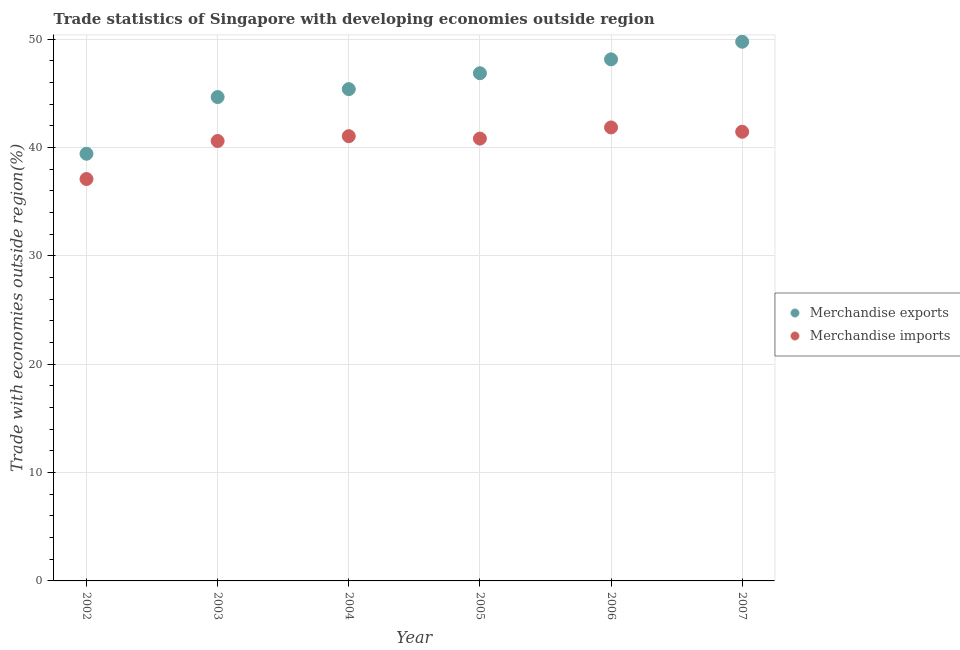What is the merchandise exports in 2005?
Provide a succinct answer. 46.87. Across all years, what is the maximum merchandise imports?
Make the answer very short. 41.87. Across all years, what is the minimum merchandise exports?
Provide a short and direct response. 39.44. What is the total merchandise exports in the graph?
Your answer should be compact. 274.31. What is the difference between the merchandise exports in 2004 and that in 2007?
Keep it short and to the point. -4.38. What is the difference between the merchandise imports in 2006 and the merchandise exports in 2002?
Ensure brevity in your answer.  2.43. What is the average merchandise imports per year?
Your response must be concise. 40.49. In the year 2003, what is the difference between the merchandise exports and merchandise imports?
Provide a short and direct response. 4.06. In how many years, is the merchandise exports greater than 30 %?
Your answer should be compact. 6. What is the ratio of the merchandise exports in 2005 to that in 2006?
Your answer should be compact. 0.97. What is the difference between the highest and the second highest merchandise imports?
Offer a very short reply. 0.4. What is the difference between the highest and the lowest merchandise exports?
Provide a short and direct response. 10.34. In how many years, is the merchandise imports greater than the average merchandise imports taken over all years?
Offer a very short reply. 5. Does the graph contain any zero values?
Provide a short and direct response. No. Does the graph contain grids?
Make the answer very short. Yes. Where does the legend appear in the graph?
Your answer should be compact. Center right. How are the legend labels stacked?
Provide a succinct answer. Vertical. What is the title of the graph?
Provide a short and direct response. Trade statistics of Singapore with developing economies outside region. Does "Excluding technical cooperation" appear as one of the legend labels in the graph?
Your response must be concise. No. What is the label or title of the X-axis?
Give a very brief answer. Year. What is the label or title of the Y-axis?
Offer a very short reply. Trade with economies outside region(%). What is the Trade with economies outside region(%) in Merchandise exports in 2002?
Make the answer very short. 39.44. What is the Trade with economies outside region(%) of Merchandise imports in 2002?
Offer a very short reply. 37.1. What is the Trade with economies outside region(%) in Merchandise exports in 2003?
Provide a short and direct response. 44.67. What is the Trade with economies outside region(%) in Merchandise imports in 2003?
Offer a very short reply. 40.61. What is the Trade with economies outside region(%) of Merchandise exports in 2004?
Ensure brevity in your answer.  45.4. What is the Trade with economies outside region(%) in Merchandise imports in 2004?
Keep it short and to the point. 41.06. What is the Trade with economies outside region(%) of Merchandise exports in 2005?
Provide a short and direct response. 46.87. What is the Trade with economies outside region(%) in Merchandise imports in 2005?
Your answer should be very brief. 40.84. What is the Trade with economies outside region(%) in Merchandise exports in 2006?
Provide a short and direct response. 48.15. What is the Trade with economies outside region(%) in Merchandise imports in 2006?
Offer a very short reply. 41.87. What is the Trade with economies outside region(%) in Merchandise exports in 2007?
Ensure brevity in your answer.  49.78. What is the Trade with economies outside region(%) of Merchandise imports in 2007?
Give a very brief answer. 41.47. Across all years, what is the maximum Trade with economies outside region(%) in Merchandise exports?
Ensure brevity in your answer.  49.78. Across all years, what is the maximum Trade with economies outside region(%) of Merchandise imports?
Make the answer very short. 41.87. Across all years, what is the minimum Trade with economies outside region(%) in Merchandise exports?
Provide a short and direct response. 39.44. Across all years, what is the minimum Trade with economies outside region(%) in Merchandise imports?
Your answer should be compact. 37.1. What is the total Trade with economies outside region(%) in Merchandise exports in the graph?
Your answer should be very brief. 274.31. What is the total Trade with economies outside region(%) of Merchandise imports in the graph?
Offer a terse response. 242.95. What is the difference between the Trade with economies outside region(%) of Merchandise exports in 2002 and that in 2003?
Keep it short and to the point. -5.23. What is the difference between the Trade with economies outside region(%) of Merchandise imports in 2002 and that in 2003?
Give a very brief answer. -3.51. What is the difference between the Trade with economies outside region(%) of Merchandise exports in 2002 and that in 2004?
Ensure brevity in your answer.  -5.96. What is the difference between the Trade with economies outside region(%) of Merchandise imports in 2002 and that in 2004?
Make the answer very short. -3.95. What is the difference between the Trade with economies outside region(%) of Merchandise exports in 2002 and that in 2005?
Make the answer very short. -7.43. What is the difference between the Trade with economies outside region(%) of Merchandise imports in 2002 and that in 2005?
Provide a short and direct response. -3.73. What is the difference between the Trade with economies outside region(%) in Merchandise exports in 2002 and that in 2006?
Offer a very short reply. -8.71. What is the difference between the Trade with economies outside region(%) in Merchandise imports in 2002 and that in 2006?
Keep it short and to the point. -4.76. What is the difference between the Trade with economies outside region(%) in Merchandise exports in 2002 and that in 2007?
Your answer should be very brief. -10.34. What is the difference between the Trade with economies outside region(%) of Merchandise imports in 2002 and that in 2007?
Your response must be concise. -4.36. What is the difference between the Trade with economies outside region(%) of Merchandise exports in 2003 and that in 2004?
Provide a succinct answer. -0.73. What is the difference between the Trade with economies outside region(%) in Merchandise imports in 2003 and that in 2004?
Give a very brief answer. -0.45. What is the difference between the Trade with economies outside region(%) in Merchandise exports in 2003 and that in 2005?
Make the answer very short. -2.2. What is the difference between the Trade with economies outside region(%) of Merchandise imports in 2003 and that in 2005?
Keep it short and to the point. -0.23. What is the difference between the Trade with economies outside region(%) in Merchandise exports in 2003 and that in 2006?
Your answer should be compact. -3.48. What is the difference between the Trade with economies outside region(%) in Merchandise imports in 2003 and that in 2006?
Your answer should be very brief. -1.25. What is the difference between the Trade with economies outside region(%) in Merchandise exports in 2003 and that in 2007?
Your answer should be very brief. -5.11. What is the difference between the Trade with economies outside region(%) in Merchandise imports in 2003 and that in 2007?
Your answer should be compact. -0.86. What is the difference between the Trade with economies outside region(%) in Merchandise exports in 2004 and that in 2005?
Your answer should be compact. -1.47. What is the difference between the Trade with economies outside region(%) of Merchandise imports in 2004 and that in 2005?
Offer a terse response. 0.22. What is the difference between the Trade with economies outside region(%) of Merchandise exports in 2004 and that in 2006?
Your answer should be very brief. -2.75. What is the difference between the Trade with economies outside region(%) in Merchandise imports in 2004 and that in 2006?
Ensure brevity in your answer.  -0.81. What is the difference between the Trade with economies outside region(%) of Merchandise exports in 2004 and that in 2007?
Ensure brevity in your answer.  -4.38. What is the difference between the Trade with economies outside region(%) in Merchandise imports in 2004 and that in 2007?
Your answer should be compact. -0.41. What is the difference between the Trade with economies outside region(%) of Merchandise exports in 2005 and that in 2006?
Your answer should be very brief. -1.28. What is the difference between the Trade with economies outside region(%) of Merchandise imports in 2005 and that in 2006?
Keep it short and to the point. -1.03. What is the difference between the Trade with economies outside region(%) in Merchandise exports in 2005 and that in 2007?
Give a very brief answer. -2.91. What is the difference between the Trade with economies outside region(%) in Merchandise imports in 2005 and that in 2007?
Make the answer very short. -0.63. What is the difference between the Trade with economies outside region(%) in Merchandise exports in 2006 and that in 2007?
Your answer should be very brief. -1.63. What is the difference between the Trade with economies outside region(%) of Merchandise imports in 2006 and that in 2007?
Provide a short and direct response. 0.4. What is the difference between the Trade with economies outside region(%) of Merchandise exports in 2002 and the Trade with economies outside region(%) of Merchandise imports in 2003?
Your answer should be compact. -1.17. What is the difference between the Trade with economies outside region(%) of Merchandise exports in 2002 and the Trade with economies outside region(%) of Merchandise imports in 2004?
Your answer should be compact. -1.62. What is the difference between the Trade with economies outside region(%) of Merchandise exports in 2002 and the Trade with economies outside region(%) of Merchandise imports in 2005?
Your response must be concise. -1.4. What is the difference between the Trade with economies outside region(%) of Merchandise exports in 2002 and the Trade with economies outside region(%) of Merchandise imports in 2006?
Keep it short and to the point. -2.43. What is the difference between the Trade with economies outside region(%) in Merchandise exports in 2002 and the Trade with economies outside region(%) in Merchandise imports in 2007?
Keep it short and to the point. -2.03. What is the difference between the Trade with economies outside region(%) in Merchandise exports in 2003 and the Trade with economies outside region(%) in Merchandise imports in 2004?
Keep it short and to the point. 3.61. What is the difference between the Trade with economies outside region(%) of Merchandise exports in 2003 and the Trade with economies outside region(%) of Merchandise imports in 2005?
Give a very brief answer. 3.83. What is the difference between the Trade with economies outside region(%) of Merchandise exports in 2003 and the Trade with economies outside region(%) of Merchandise imports in 2006?
Offer a terse response. 2.8. What is the difference between the Trade with economies outside region(%) of Merchandise exports in 2003 and the Trade with economies outside region(%) of Merchandise imports in 2007?
Provide a short and direct response. 3.2. What is the difference between the Trade with economies outside region(%) in Merchandise exports in 2004 and the Trade with economies outside region(%) in Merchandise imports in 2005?
Provide a succinct answer. 4.56. What is the difference between the Trade with economies outside region(%) in Merchandise exports in 2004 and the Trade with economies outside region(%) in Merchandise imports in 2006?
Offer a very short reply. 3.54. What is the difference between the Trade with economies outside region(%) of Merchandise exports in 2004 and the Trade with economies outside region(%) of Merchandise imports in 2007?
Offer a very short reply. 3.93. What is the difference between the Trade with economies outside region(%) of Merchandise exports in 2005 and the Trade with economies outside region(%) of Merchandise imports in 2006?
Your answer should be compact. 5. What is the difference between the Trade with economies outside region(%) of Merchandise exports in 2005 and the Trade with economies outside region(%) of Merchandise imports in 2007?
Your answer should be very brief. 5.4. What is the difference between the Trade with economies outside region(%) in Merchandise exports in 2006 and the Trade with economies outside region(%) in Merchandise imports in 2007?
Your answer should be very brief. 6.68. What is the average Trade with economies outside region(%) in Merchandise exports per year?
Your answer should be compact. 45.72. What is the average Trade with economies outside region(%) in Merchandise imports per year?
Offer a very short reply. 40.49. In the year 2002, what is the difference between the Trade with economies outside region(%) of Merchandise exports and Trade with economies outside region(%) of Merchandise imports?
Ensure brevity in your answer.  2.33. In the year 2003, what is the difference between the Trade with economies outside region(%) in Merchandise exports and Trade with economies outside region(%) in Merchandise imports?
Ensure brevity in your answer.  4.06. In the year 2004, what is the difference between the Trade with economies outside region(%) in Merchandise exports and Trade with economies outside region(%) in Merchandise imports?
Your answer should be compact. 4.34. In the year 2005, what is the difference between the Trade with economies outside region(%) in Merchandise exports and Trade with economies outside region(%) in Merchandise imports?
Offer a very short reply. 6.03. In the year 2006, what is the difference between the Trade with economies outside region(%) in Merchandise exports and Trade with economies outside region(%) in Merchandise imports?
Provide a short and direct response. 6.28. In the year 2007, what is the difference between the Trade with economies outside region(%) in Merchandise exports and Trade with economies outside region(%) in Merchandise imports?
Make the answer very short. 8.31. What is the ratio of the Trade with economies outside region(%) of Merchandise exports in 2002 to that in 2003?
Offer a very short reply. 0.88. What is the ratio of the Trade with economies outside region(%) of Merchandise imports in 2002 to that in 2003?
Offer a terse response. 0.91. What is the ratio of the Trade with economies outside region(%) in Merchandise exports in 2002 to that in 2004?
Offer a very short reply. 0.87. What is the ratio of the Trade with economies outside region(%) of Merchandise imports in 2002 to that in 2004?
Keep it short and to the point. 0.9. What is the ratio of the Trade with economies outside region(%) of Merchandise exports in 2002 to that in 2005?
Your answer should be very brief. 0.84. What is the ratio of the Trade with economies outside region(%) of Merchandise imports in 2002 to that in 2005?
Provide a succinct answer. 0.91. What is the ratio of the Trade with economies outside region(%) of Merchandise exports in 2002 to that in 2006?
Give a very brief answer. 0.82. What is the ratio of the Trade with economies outside region(%) in Merchandise imports in 2002 to that in 2006?
Ensure brevity in your answer.  0.89. What is the ratio of the Trade with economies outside region(%) in Merchandise exports in 2002 to that in 2007?
Make the answer very short. 0.79. What is the ratio of the Trade with economies outside region(%) of Merchandise imports in 2002 to that in 2007?
Provide a short and direct response. 0.89. What is the ratio of the Trade with economies outside region(%) in Merchandise exports in 2003 to that in 2004?
Your response must be concise. 0.98. What is the ratio of the Trade with economies outside region(%) of Merchandise exports in 2003 to that in 2005?
Provide a short and direct response. 0.95. What is the ratio of the Trade with economies outside region(%) in Merchandise imports in 2003 to that in 2005?
Provide a short and direct response. 0.99. What is the ratio of the Trade with economies outside region(%) in Merchandise exports in 2003 to that in 2006?
Offer a terse response. 0.93. What is the ratio of the Trade with economies outside region(%) in Merchandise exports in 2003 to that in 2007?
Provide a short and direct response. 0.9. What is the ratio of the Trade with economies outside region(%) in Merchandise imports in 2003 to that in 2007?
Your answer should be very brief. 0.98. What is the ratio of the Trade with economies outside region(%) of Merchandise exports in 2004 to that in 2005?
Keep it short and to the point. 0.97. What is the ratio of the Trade with economies outside region(%) of Merchandise imports in 2004 to that in 2005?
Provide a succinct answer. 1.01. What is the ratio of the Trade with economies outside region(%) of Merchandise exports in 2004 to that in 2006?
Provide a succinct answer. 0.94. What is the ratio of the Trade with economies outside region(%) in Merchandise imports in 2004 to that in 2006?
Ensure brevity in your answer.  0.98. What is the ratio of the Trade with economies outside region(%) of Merchandise exports in 2004 to that in 2007?
Your answer should be compact. 0.91. What is the ratio of the Trade with economies outside region(%) in Merchandise imports in 2004 to that in 2007?
Provide a short and direct response. 0.99. What is the ratio of the Trade with economies outside region(%) of Merchandise exports in 2005 to that in 2006?
Ensure brevity in your answer.  0.97. What is the ratio of the Trade with economies outside region(%) in Merchandise imports in 2005 to that in 2006?
Your answer should be compact. 0.98. What is the ratio of the Trade with economies outside region(%) of Merchandise exports in 2005 to that in 2007?
Offer a very short reply. 0.94. What is the ratio of the Trade with economies outside region(%) in Merchandise exports in 2006 to that in 2007?
Your response must be concise. 0.97. What is the ratio of the Trade with economies outside region(%) of Merchandise imports in 2006 to that in 2007?
Your answer should be compact. 1.01. What is the difference between the highest and the second highest Trade with economies outside region(%) of Merchandise exports?
Your response must be concise. 1.63. What is the difference between the highest and the second highest Trade with economies outside region(%) of Merchandise imports?
Your answer should be compact. 0.4. What is the difference between the highest and the lowest Trade with economies outside region(%) in Merchandise exports?
Offer a terse response. 10.34. What is the difference between the highest and the lowest Trade with economies outside region(%) of Merchandise imports?
Offer a terse response. 4.76. 